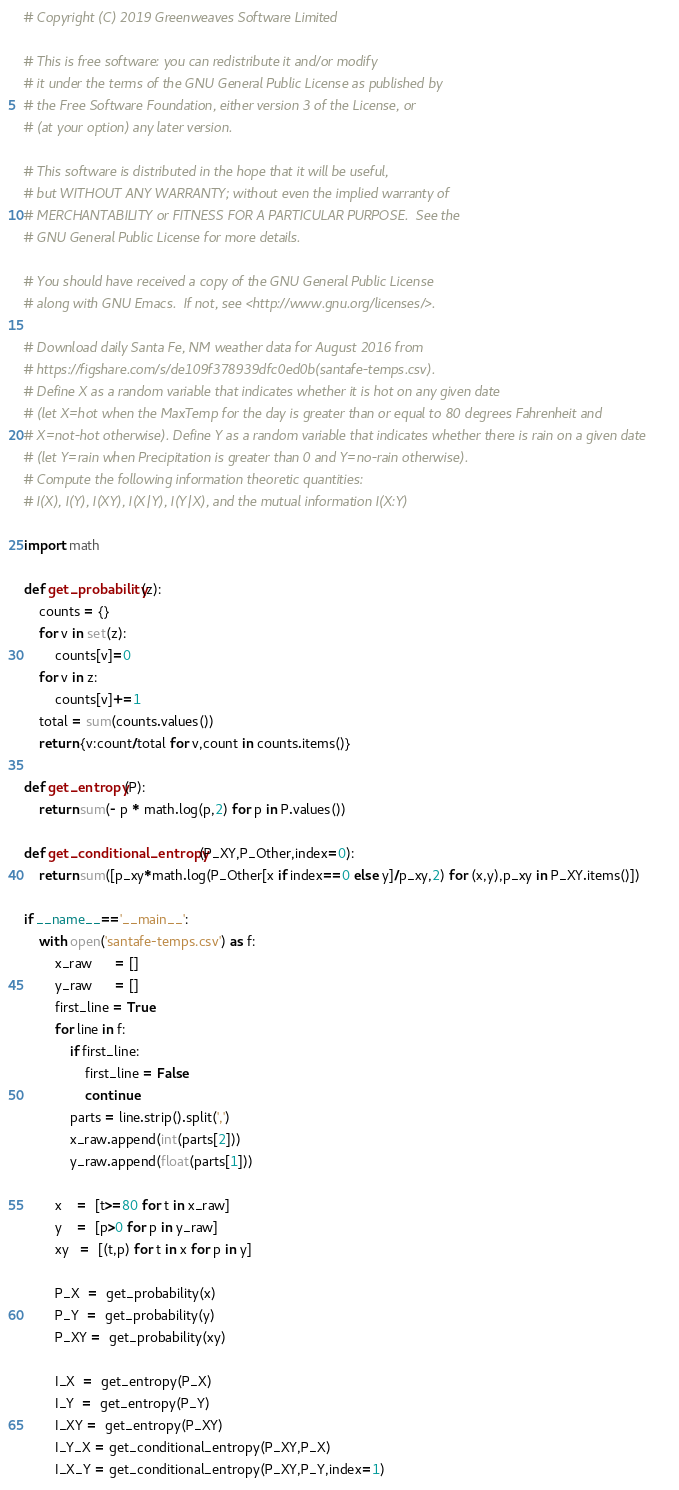<code> <loc_0><loc_0><loc_500><loc_500><_Python_># Copyright (C) 2019 Greenweaves Software Limited

# This is free software: you can redistribute it and/or modify
# it under the terms of the GNU General Public License as published by
# the Free Software Foundation, either version 3 of the License, or
# (at your option) any later version.

# This software is distributed in the hope that it will be useful,
# but WITHOUT ANY WARRANTY; without even the implied warranty of
# MERCHANTABILITY or FITNESS FOR A PARTICULAR PURPOSE.  See the
# GNU General Public License for more details.

# You should have received a copy of the GNU General Public License
# along with GNU Emacs.  If not, see <http://www.gnu.org/licenses/>.

# Download daily Santa Fe, NM weather data for August 2016 from 
# https://figshare.com/s/de109f378939dfc0ed0b(santafe-temps.csv).
# Define X as a random variable that indicates whether it is hot on any given date
# (let X=hot when the MaxTemp for the day is greater than or equal to 80 degrees Fahrenheit and 
# X=not-hot otherwise). Define Y as a random variable that indicates whether there is rain on a given date
# (let Y=rain when Precipitation is greater than 0 and Y=no-rain otherwise).
# Compute the following information theoretic quantities: 
# I(X), I(Y), I(XY), I(X|Y), I(Y|X), and the mutual information I(X:Y)

import math

def get_probability(z):
    counts = {}
    for v in set(z):
        counts[v]=0
    for v in z:
        counts[v]+=1
    total = sum(counts.values())
    return {v:count/total for v,count in counts.items()}
    
def get_entropy(P):
    return sum(- p * math.log(p,2) for p in P.values())

def get_conditional_entropy(P_XY,P_Other,index=0):
    return sum([p_xy*math.log(P_Other[x if index==0 else y]/p_xy,2) for (x,y),p_xy in P_XY.items()])

if __name__=='__main__':
    with open('santafe-temps.csv') as f:
        x_raw      = []
        y_raw      = []
        first_line = True
        for line in f:
            if first_line:
                first_line = False
                continue
            parts = line.strip().split(',')
            x_raw.append(int(parts[2]))
            y_raw.append(float(parts[1]))
            
        x    =  [t>=80 for t in x_raw]
        y    =  [p>0 for p in y_raw]
        xy   =  [(t,p) for t in x for p in y]
        
        P_X  =  get_probability(x)
        P_Y  =  get_probability(y)
        P_XY =  get_probability(xy)
        
        I_X  =  get_entropy(P_X)
        I_Y  =  get_entropy(P_Y)
        I_XY =  get_entropy(P_XY)
        I_Y_X = get_conditional_entropy(P_XY,P_X)
        I_X_Y = get_conditional_entropy(P_XY,P_Y,index=1)        </code> 